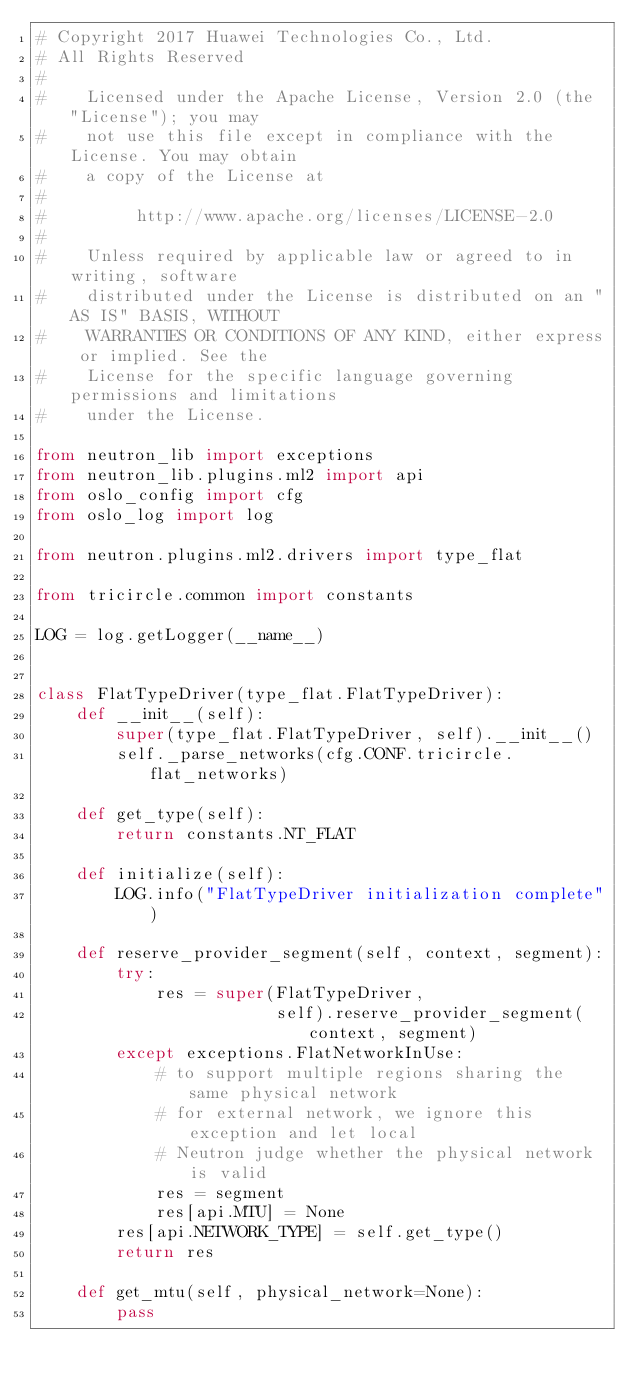Convert code to text. <code><loc_0><loc_0><loc_500><loc_500><_Python_># Copyright 2017 Huawei Technologies Co., Ltd.
# All Rights Reserved
#
#    Licensed under the Apache License, Version 2.0 (the "License"); you may
#    not use this file except in compliance with the License. You may obtain
#    a copy of the License at
#
#         http://www.apache.org/licenses/LICENSE-2.0
#
#    Unless required by applicable law or agreed to in writing, software
#    distributed under the License is distributed on an "AS IS" BASIS, WITHOUT
#    WARRANTIES OR CONDITIONS OF ANY KIND, either express or implied. See the
#    License for the specific language governing permissions and limitations
#    under the License.

from neutron_lib import exceptions
from neutron_lib.plugins.ml2 import api
from oslo_config import cfg
from oslo_log import log

from neutron.plugins.ml2.drivers import type_flat

from tricircle.common import constants

LOG = log.getLogger(__name__)


class FlatTypeDriver(type_flat.FlatTypeDriver):
    def __init__(self):
        super(type_flat.FlatTypeDriver, self).__init__()
        self._parse_networks(cfg.CONF.tricircle.flat_networks)

    def get_type(self):
        return constants.NT_FLAT

    def initialize(self):
        LOG.info("FlatTypeDriver initialization complete")

    def reserve_provider_segment(self, context, segment):
        try:
            res = super(FlatTypeDriver,
                        self).reserve_provider_segment(context, segment)
        except exceptions.FlatNetworkInUse:
            # to support multiple regions sharing the same physical network
            # for external network, we ignore this exception and let local
            # Neutron judge whether the physical network is valid
            res = segment
            res[api.MTU] = None
        res[api.NETWORK_TYPE] = self.get_type()
        return res

    def get_mtu(self, physical_network=None):
        pass
</code> 